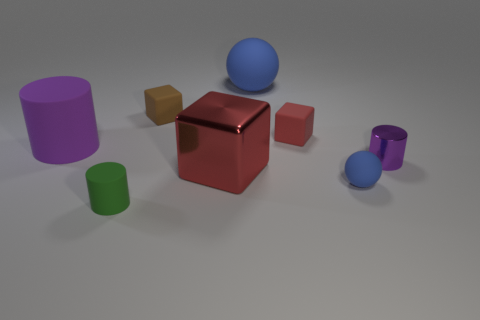What number of other things are the same size as the red metal thing?
Offer a terse response. 2. Are there any rubber things of the same size as the red metallic object?
Your answer should be very brief. Yes. Do the cylinder that is behind the small shiny cylinder and the tiny sphere have the same color?
Keep it short and to the point. No. How many objects are cyan metal cylinders or small red blocks?
Your response must be concise. 1. Is the size of the blue rubber object that is in front of the red matte cube the same as the small rubber cylinder?
Provide a succinct answer. Yes. There is a rubber object that is in front of the purple metal object and behind the tiny rubber cylinder; how big is it?
Give a very brief answer. Small. How many other objects are the same shape as the red metallic object?
Give a very brief answer. 2. What number of other things are the same material as the tiny brown block?
Your answer should be compact. 5. There is a red matte thing that is the same shape as the tiny brown matte thing; what is its size?
Your answer should be very brief. Small. Is the big rubber cylinder the same color as the tiny sphere?
Ensure brevity in your answer.  No. 